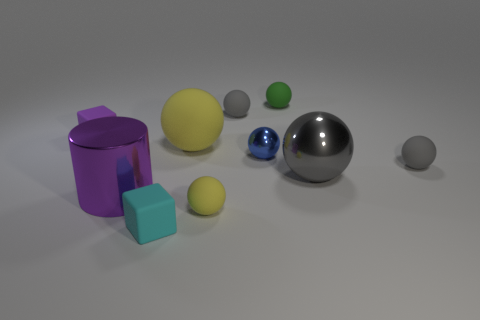Subtract all big matte balls. How many balls are left? 6 Subtract all green cylinders. How many yellow balls are left? 2 Subtract 1 spheres. How many spheres are left? 6 Subtract all green balls. How many balls are left? 6 Subtract all blocks. How many objects are left? 8 Subtract all yellow balls. Subtract all red cylinders. How many balls are left? 5 Add 1 small matte objects. How many small matte objects are left? 7 Add 9 tiny green spheres. How many tiny green spheres exist? 10 Subtract 0 brown spheres. How many objects are left? 10 Subtract all green spheres. Subtract all purple shiny cylinders. How many objects are left? 8 